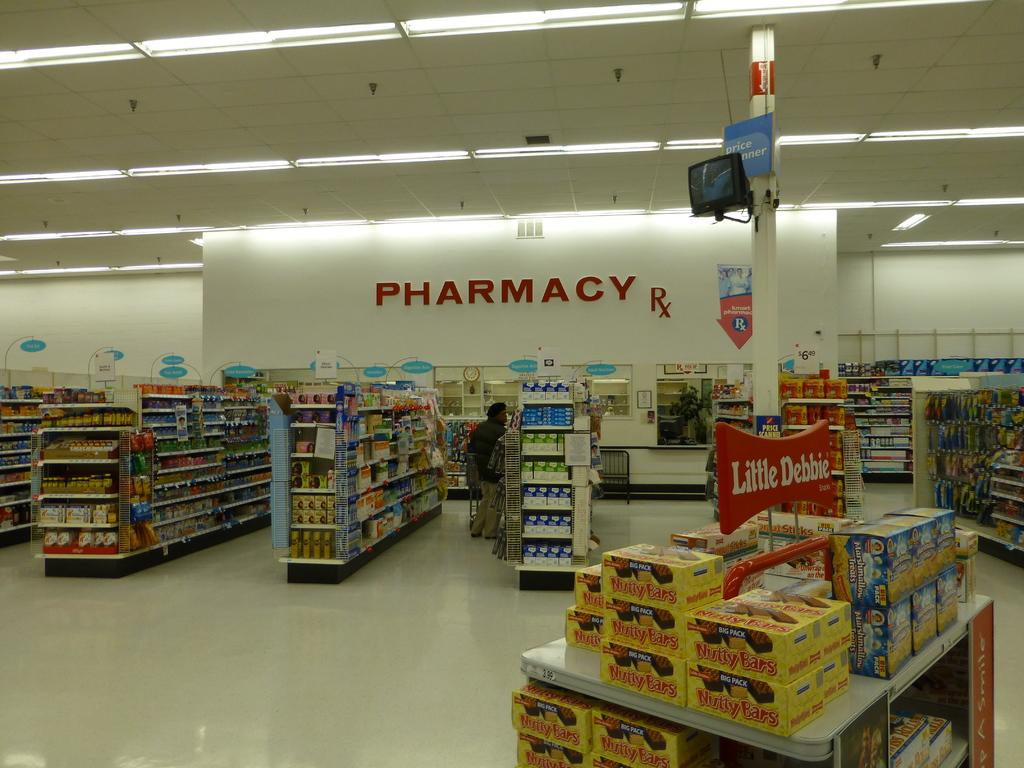<image>
Offer a succinct explanation of the picture presented. a store with the pharmacy in the back 